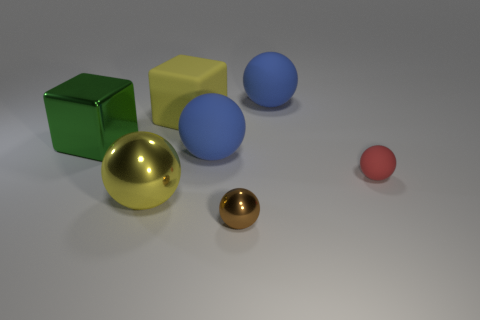Does the large block to the right of the big yellow sphere have the same color as the metal ball that is on the left side of the small brown sphere?
Your response must be concise. Yes. Are there any other objects that have the same shape as the big green metallic object?
Your answer should be very brief. Yes. There is a blue matte object in front of the green block; what is its shape?
Offer a terse response. Sphere. There is a blue thing that is behind the blue rubber sphere that is in front of the metal cube; what number of big things are in front of it?
Provide a succinct answer. 4. There is a metal ball that is behind the tiny brown sphere; is it the same color as the big rubber block?
Give a very brief answer. Yes. How many other objects are there of the same shape as the big yellow metal object?
Your answer should be compact. 4. How many other objects are the same material as the large yellow cube?
Make the answer very short. 3. There is a small object that is left of the big blue matte thing that is behind the large block that is in front of the yellow matte thing; what is its material?
Give a very brief answer. Metal. Is the material of the yellow block the same as the red thing?
Provide a short and direct response. Yes. How many blocks are metal things or big yellow matte objects?
Make the answer very short. 2. 